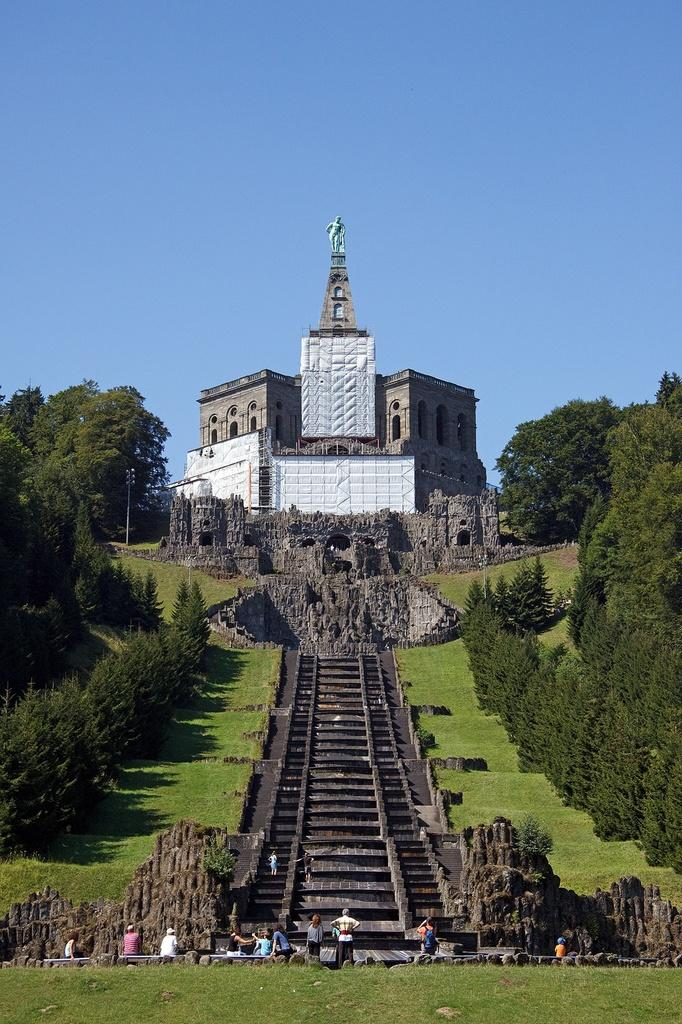What type of structures can be seen in the image? There are buildings in the image. What architectural feature is present in the image? There are stairs in the image. Are there any living beings in the image? Yes, there are people in the image. What type of vegetation is present in the image? There are trees with green color in the image. What can be seen in the sky in the image? The sky is visible in the image and has a blue color. Can you see any toes on the people in the image? There is no specific detail about the people's toes in the image, so it cannot be determined if they are visible or not. What type of button can be seen on the trees in the image? There are no buttons present on the trees in the image; they are natural vegetation. Is there a snake visible in the image? There is no snake present in the image. 